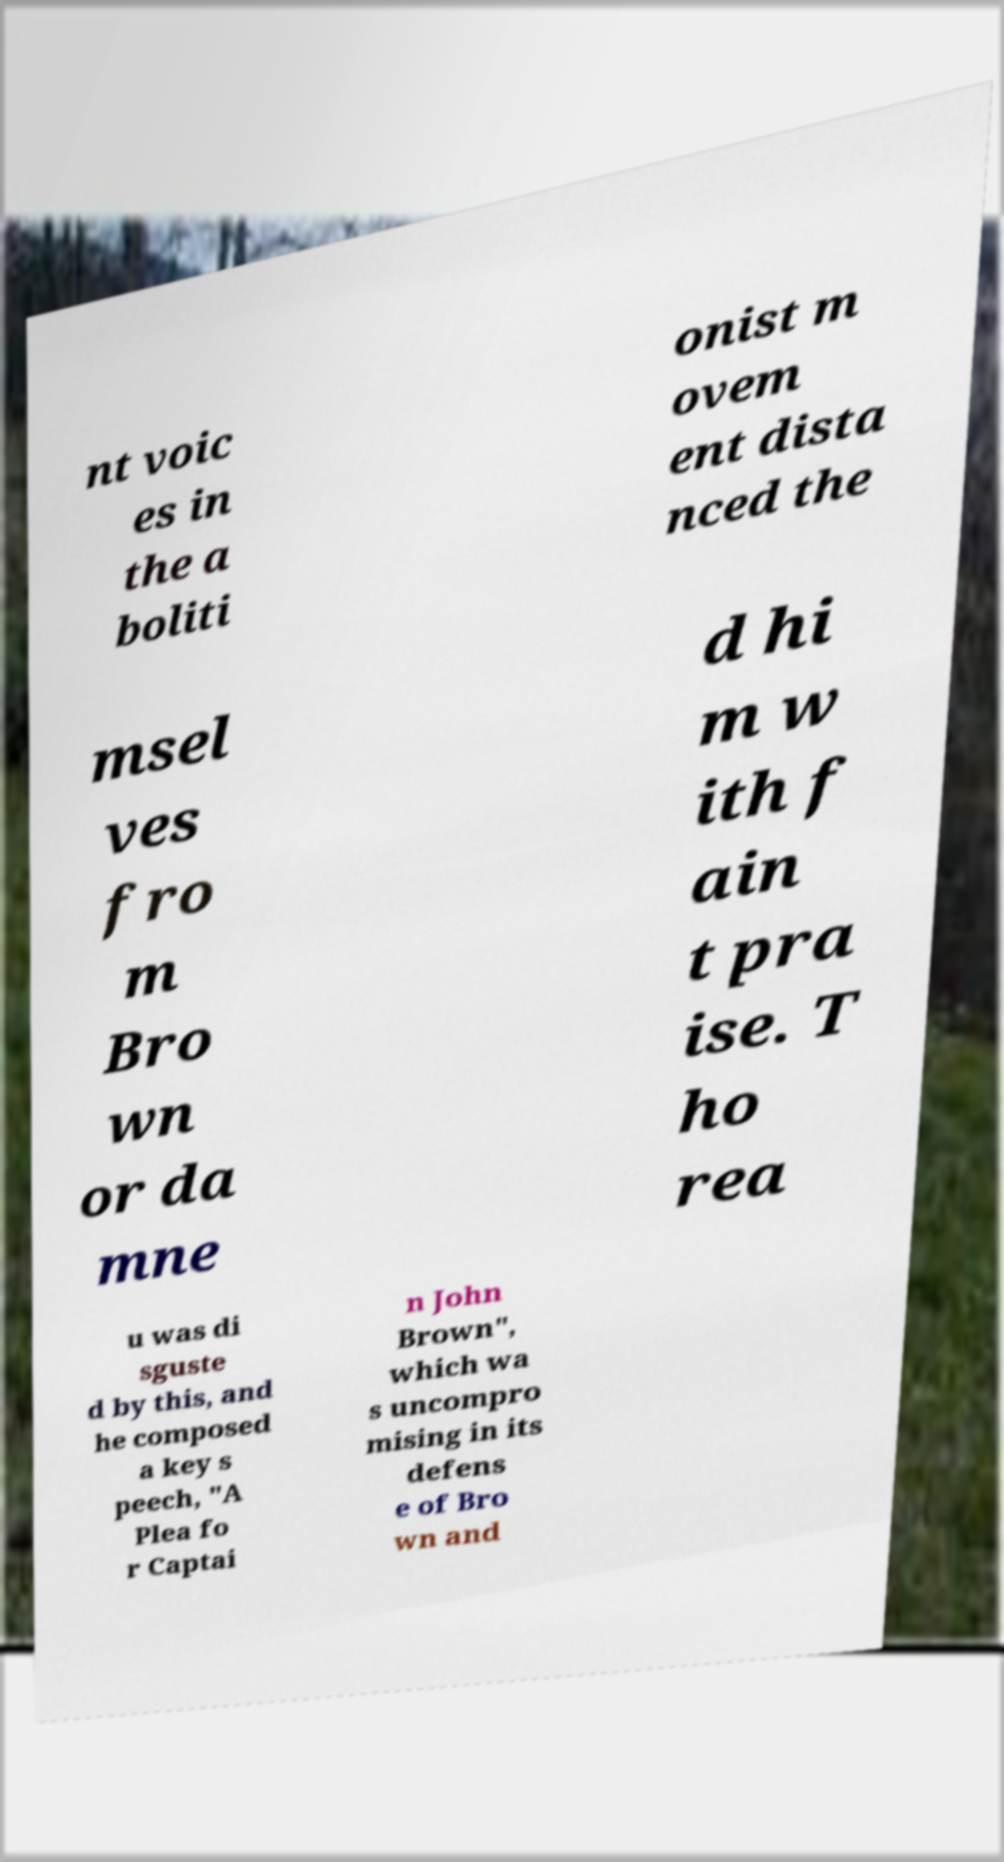Can you accurately transcribe the text from the provided image for me? nt voic es in the a boliti onist m ovem ent dista nced the msel ves fro m Bro wn or da mne d hi m w ith f ain t pra ise. T ho rea u was di sguste d by this, and he composed a key s peech, "A Plea fo r Captai n John Brown", which wa s uncompro mising in its defens e of Bro wn and 